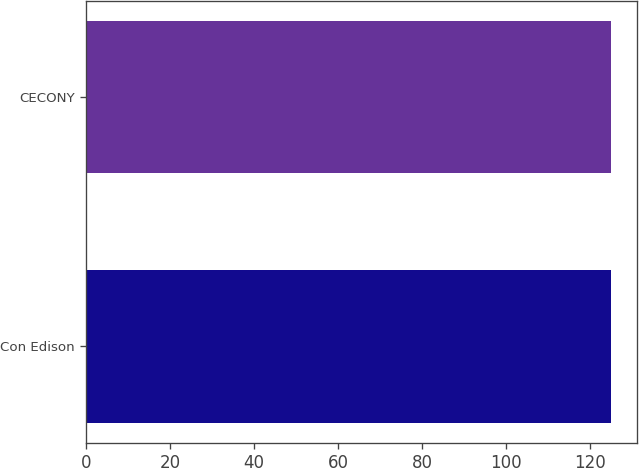<chart> <loc_0><loc_0><loc_500><loc_500><bar_chart><fcel>Con Edison<fcel>CECONY<nl><fcel>125<fcel>125.1<nl></chart> 